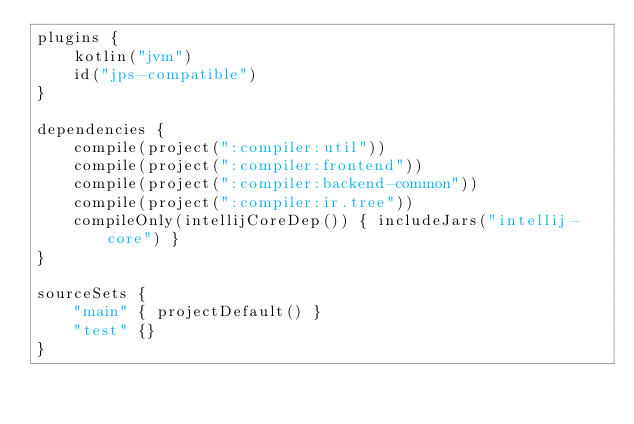<code> <loc_0><loc_0><loc_500><loc_500><_Kotlin_>plugins {
    kotlin("jvm")
    id("jps-compatible")
}

dependencies {
    compile(project(":compiler:util"))
    compile(project(":compiler:frontend"))
    compile(project(":compiler:backend-common"))
    compile(project(":compiler:ir.tree"))
    compileOnly(intellijCoreDep()) { includeJars("intellij-core") }
}

sourceSets {
    "main" { projectDefault() }
    "test" {}
}

</code> 